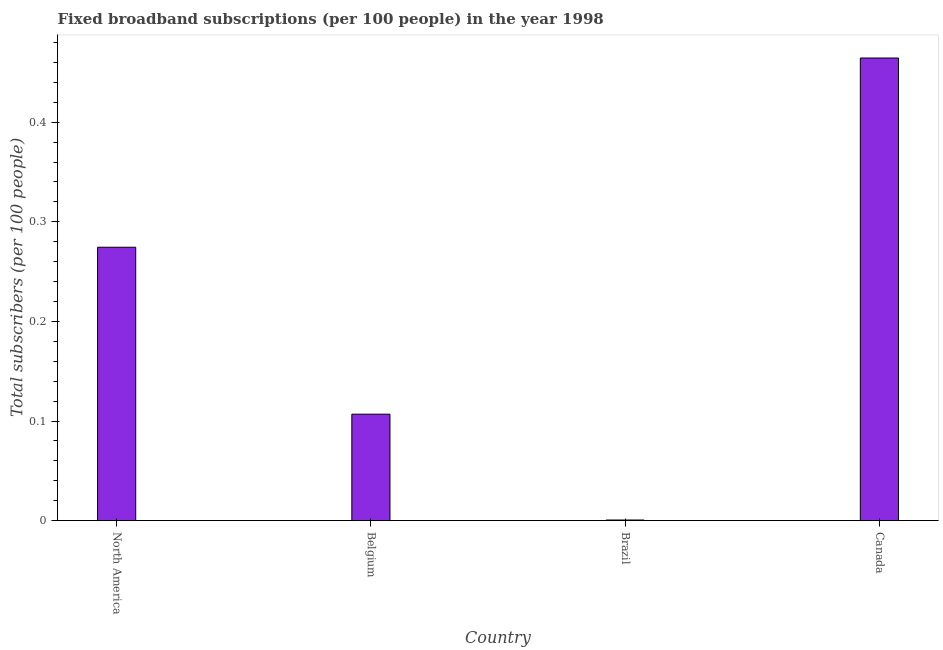Does the graph contain grids?
Your response must be concise. No. What is the title of the graph?
Offer a terse response. Fixed broadband subscriptions (per 100 people) in the year 1998. What is the label or title of the Y-axis?
Your answer should be compact. Total subscribers (per 100 people). What is the total number of fixed broadband subscriptions in Canada?
Your answer should be very brief. 0.46. Across all countries, what is the maximum total number of fixed broadband subscriptions?
Your answer should be very brief. 0.46. Across all countries, what is the minimum total number of fixed broadband subscriptions?
Ensure brevity in your answer.  0. In which country was the total number of fixed broadband subscriptions maximum?
Ensure brevity in your answer.  Canada. In which country was the total number of fixed broadband subscriptions minimum?
Give a very brief answer. Brazil. What is the sum of the total number of fixed broadband subscriptions?
Provide a short and direct response. 0.85. What is the difference between the total number of fixed broadband subscriptions in Belgium and Canada?
Offer a very short reply. -0.36. What is the average total number of fixed broadband subscriptions per country?
Your answer should be compact. 0.21. What is the median total number of fixed broadband subscriptions?
Make the answer very short. 0.19. What is the ratio of the total number of fixed broadband subscriptions in Belgium to that in North America?
Provide a short and direct response. 0.39. Is the total number of fixed broadband subscriptions in Belgium less than that in North America?
Provide a succinct answer. Yes. What is the difference between the highest and the second highest total number of fixed broadband subscriptions?
Your response must be concise. 0.19. Is the sum of the total number of fixed broadband subscriptions in Belgium and Brazil greater than the maximum total number of fixed broadband subscriptions across all countries?
Ensure brevity in your answer.  No. What is the difference between the highest and the lowest total number of fixed broadband subscriptions?
Your answer should be very brief. 0.46. How many bars are there?
Provide a short and direct response. 4. What is the difference between two consecutive major ticks on the Y-axis?
Your answer should be very brief. 0.1. What is the Total subscribers (per 100 people) in North America?
Your answer should be compact. 0.27. What is the Total subscribers (per 100 people) of Belgium?
Offer a very short reply. 0.11. What is the Total subscribers (per 100 people) in Brazil?
Keep it short and to the point. 0. What is the Total subscribers (per 100 people) in Canada?
Offer a very short reply. 0.46. What is the difference between the Total subscribers (per 100 people) in North America and Belgium?
Offer a very short reply. 0.17. What is the difference between the Total subscribers (per 100 people) in North America and Brazil?
Offer a very short reply. 0.27. What is the difference between the Total subscribers (per 100 people) in North America and Canada?
Make the answer very short. -0.19. What is the difference between the Total subscribers (per 100 people) in Belgium and Brazil?
Give a very brief answer. 0.11. What is the difference between the Total subscribers (per 100 people) in Belgium and Canada?
Your response must be concise. -0.36. What is the difference between the Total subscribers (per 100 people) in Brazil and Canada?
Make the answer very short. -0.46. What is the ratio of the Total subscribers (per 100 people) in North America to that in Belgium?
Your response must be concise. 2.57. What is the ratio of the Total subscribers (per 100 people) in North America to that in Brazil?
Make the answer very short. 465.15. What is the ratio of the Total subscribers (per 100 people) in North America to that in Canada?
Offer a terse response. 0.59. What is the ratio of the Total subscribers (per 100 people) in Belgium to that in Brazil?
Your answer should be compact. 181.09. What is the ratio of the Total subscribers (per 100 people) in Belgium to that in Canada?
Provide a short and direct response. 0.23. 